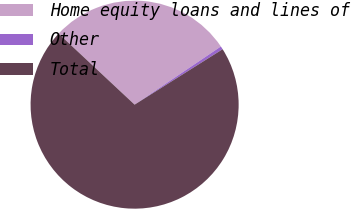Convert chart to OTSL. <chart><loc_0><loc_0><loc_500><loc_500><pie_chart><fcel>Home equity loans and lines of<fcel>Other<fcel>Total<nl><fcel>28.6%<fcel>0.5%<fcel>70.91%<nl></chart> 